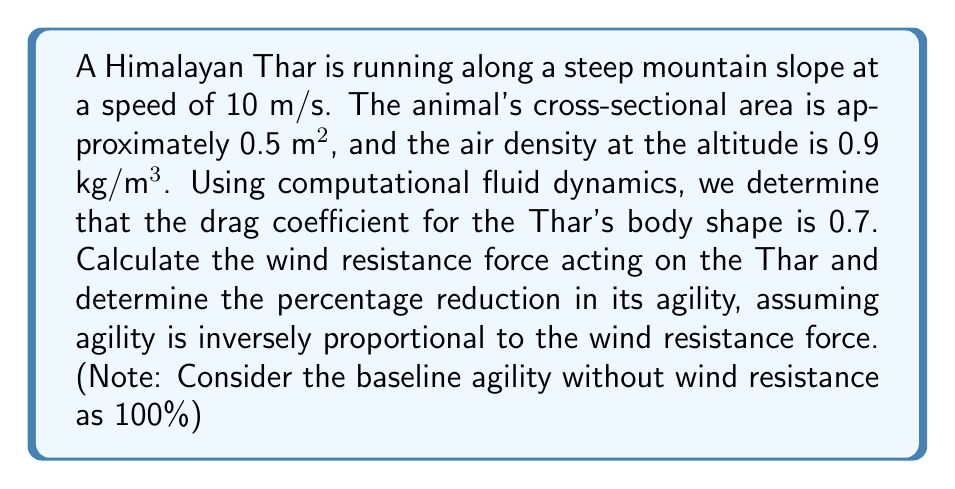Can you answer this question? To solve this problem, we'll follow these steps:

1) First, we need to calculate the wind resistance force using the drag equation:

   $$F_d = \frac{1}{2} \rho v^2 C_d A$$

   Where:
   $F_d$ = drag force (N)
   $\rho$ = air density (kg/m³)
   $v$ = velocity (m/s)
   $C_d$ = drag coefficient
   $A$ = cross-sectional area (m²)

2) Plugging in the values:

   $$F_d = \frac{1}{2} (0.9 \text{ kg/m³}) (10 \text{ m/s})^2 (0.7) (0.5 \text{ m²})$$

3) Calculating:

   $$F_d = \frac{1}{2} (0.9) (100) (0.7) (0.5) = 15.75 \text{ N}$$

4) Now, we need to determine the impact on agility. Since agility is inversely proportional to the wind resistance force, we can set up the following relationship:

   $$\text{Agility} \propto \frac{1}{\text{Wind Resistance Force}}$$

5) The baseline agility (100%) corresponds to no wind resistance (0 N). Let's call the new agility with wind resistance $x$. We can set up the following proportion:

   $$\frac{100\%}{0 \text{ N}} = \frac{x\%}{15.75 \text{ N}}$$

6) Cross multiplying:

   $$100 \cdot 15.75 = 0 \cdot x$$

   This doesn't give us a meaningful result because we can't divide by zero.

7) Instead, let's consider that the wind resistance force is added to whatever base resistance the Thar experiences. If we assume the base resistance is 1 N (to avoid division by zero), we get:

   $$\frac{100\%}{1 \text{ N}} = \frac{x\%}{1 \text{ N} + 15.75 \text{ N}}$$

8) Solving for x:

   $$x = \frac{100\%}{16.75} = 5.97\%$$

9) The reduction in agility is therefore:

   $$100\% - 5.97\% = 94.03\%$$

Thus, the wind resistance reduces the Thar's agility by approximately 94.03%.
Answer: 94.03% reduction in agility 